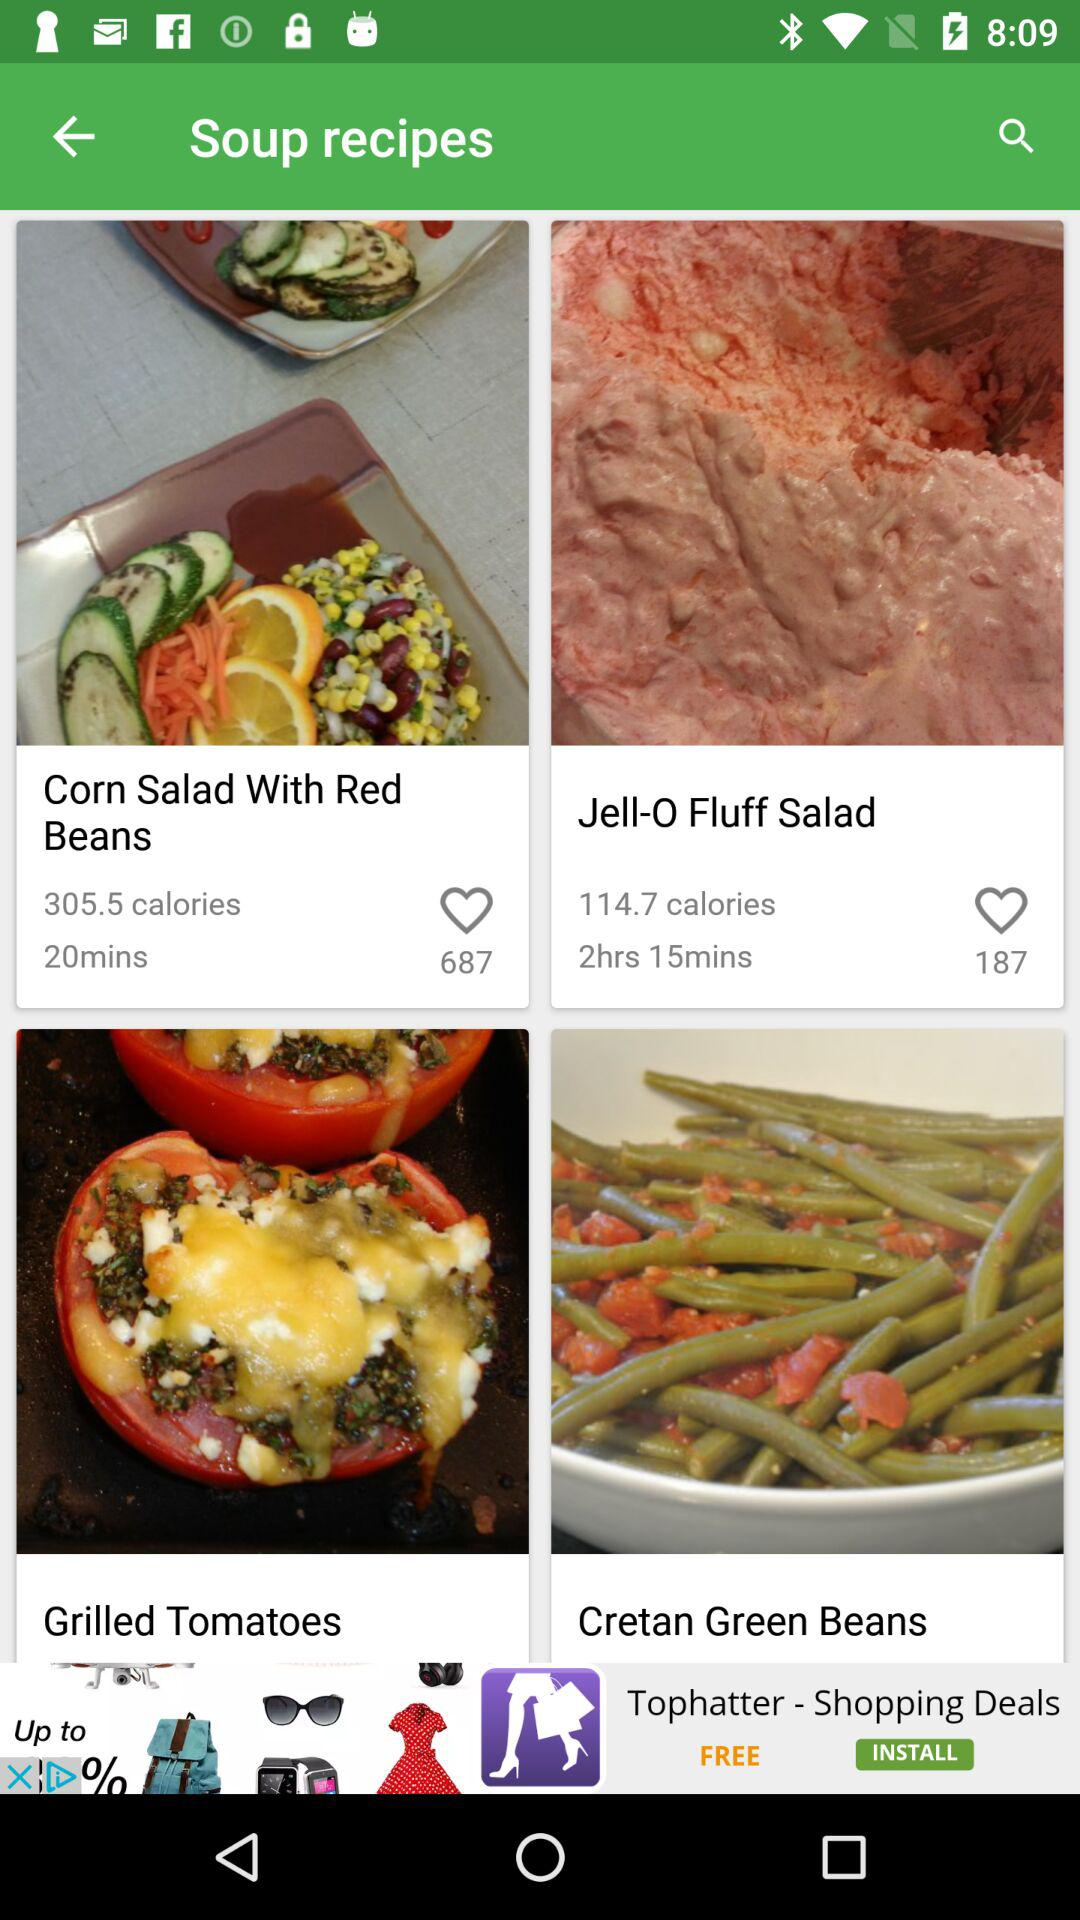How much time will it take to prepare the "Corn Salad With Red Beans"? It will take 20 minutes to prepare the "Corn Salad With Red Beans". 